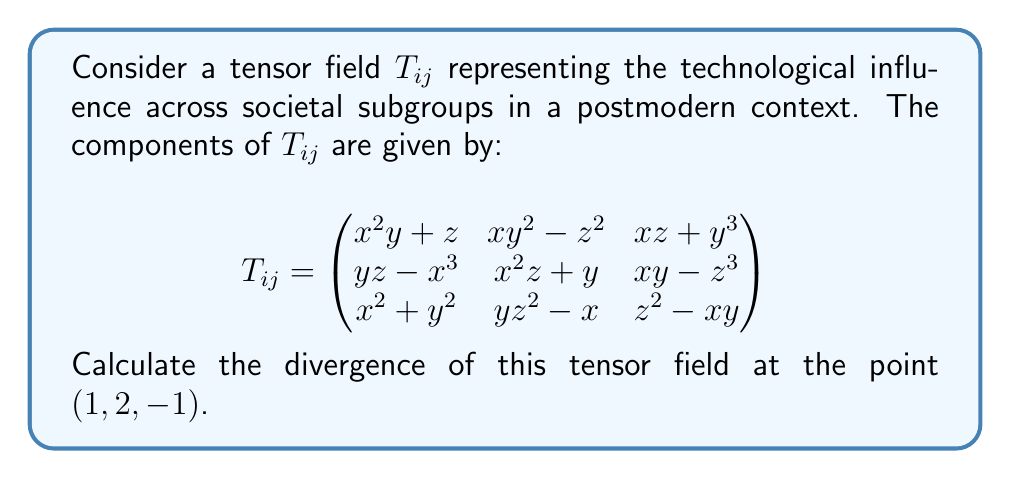What is the answer to this math problem? To calculate the divergence of a tensor field, we need to sum the partial derivatives of the diagonal elements with respect to their corresponding variables. The divergence is given by:

$$\text{div}(T_{ij}) = \frac{\partial T_{11}}{\partial x} + \frac{\partial T_{22}}{\partial y} + \frac{\partial T_{33}}{\partial z}$$

Let's calculate each term:

1) $\frac{\partial T_{11}}{\partial x}$:
   $T_{11} = x^2y + z$
   $\frac{\partial T_{11}}{\partial x} = 2xy$
   At $(1, 2, -1)$: $2(1)(2) = 4$

2) $\frac{\partial T_{22}}{\partial y}$:
   $T_{22} = x^2z + y$
   $\frac{\partial T_{22}}{\partial y} = 1$
   At $(1, 2, -1)$: $1$

3) $\frac{\partial T_{33}}{\partial z}$:
   $T_{33} = z^2 - xy$
   $\frac{\partial T_{33}}{\partial z} = 2z$
   At $(1, 2, -1)$: $2(-1) = -2$

Now, we sum these values:

$$\text{div}(T_{ij}) = 4 + 1 + (-2) = 3$$

This result represents the rate at which technological influence is "flowing" out of the point $(1, 2, -1)$ in our postmodern societal context.
Answer: $3$ 